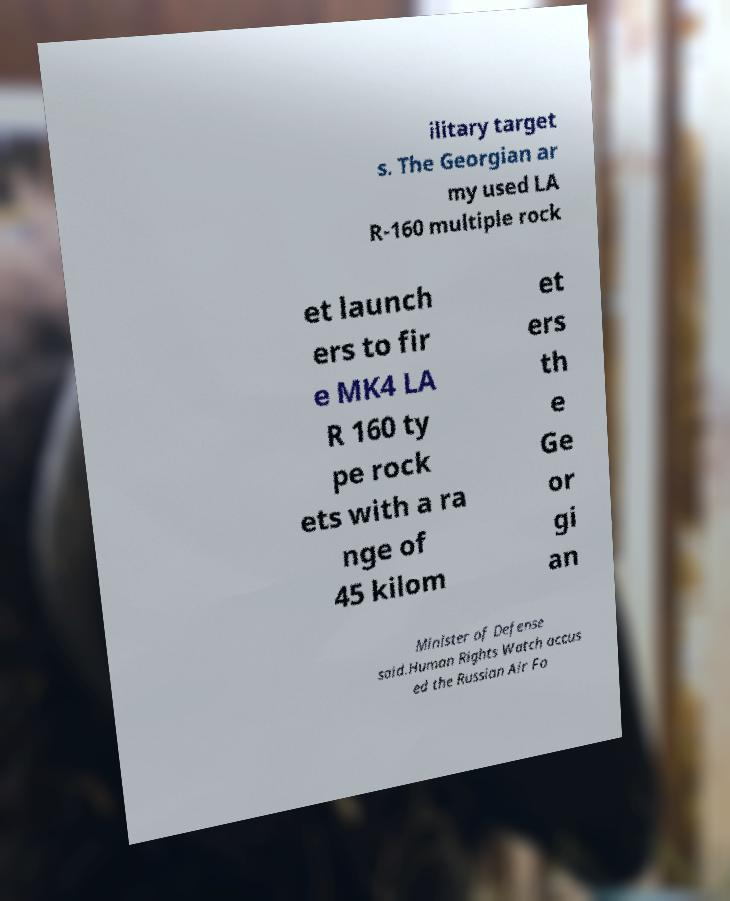Please identify and transcribe the text found in this image. ilitary target s. The Georgian ar my used LA R-160 multiple rock et launch ers to fir e MK4 LA R 160 ty pe rock ets with a ra nge of 45 kilom et ers th e Ge or gi an Minister of Defense said.Human Rights Watch accus ed the Russian Air Fo 